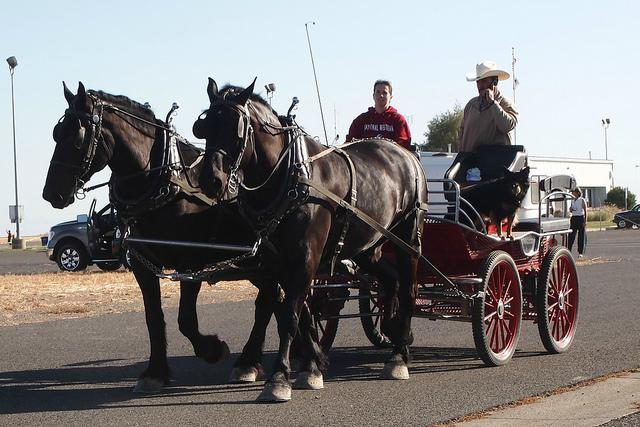What are the horses doing? pulling wagon 